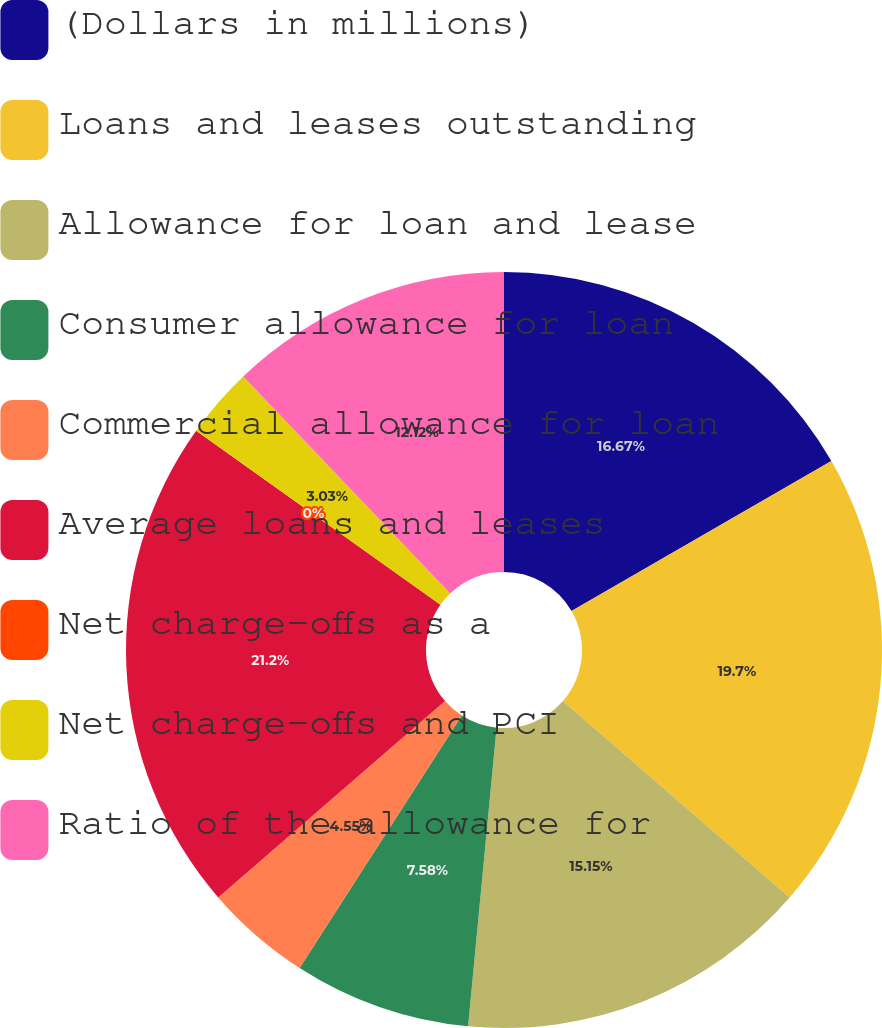Convert chart. <chart><loc_0><loc_0><loc_500><loc_500><pie_chart><fcel>(Dollars in millions)<fcel>Loans and leases outstanding<fcel>Allowance for loan and lease<fcel>Consumer allowance for loan<fcel>Commercial allowance for loan<fcel>Average loans and leases<fcel>Net charge-offs as a<fcel>Net charge-offs and PCI<fcel>Ratio of the allowance for<nl><fcel>16.67%<fcel>19.7%<fcel>15.15%<fcel>7.58%<fcel>4.55%<fcel>21.21%<fcel>0.0%<fcel>3.03%<fcel>12.12%<nl></chart> 